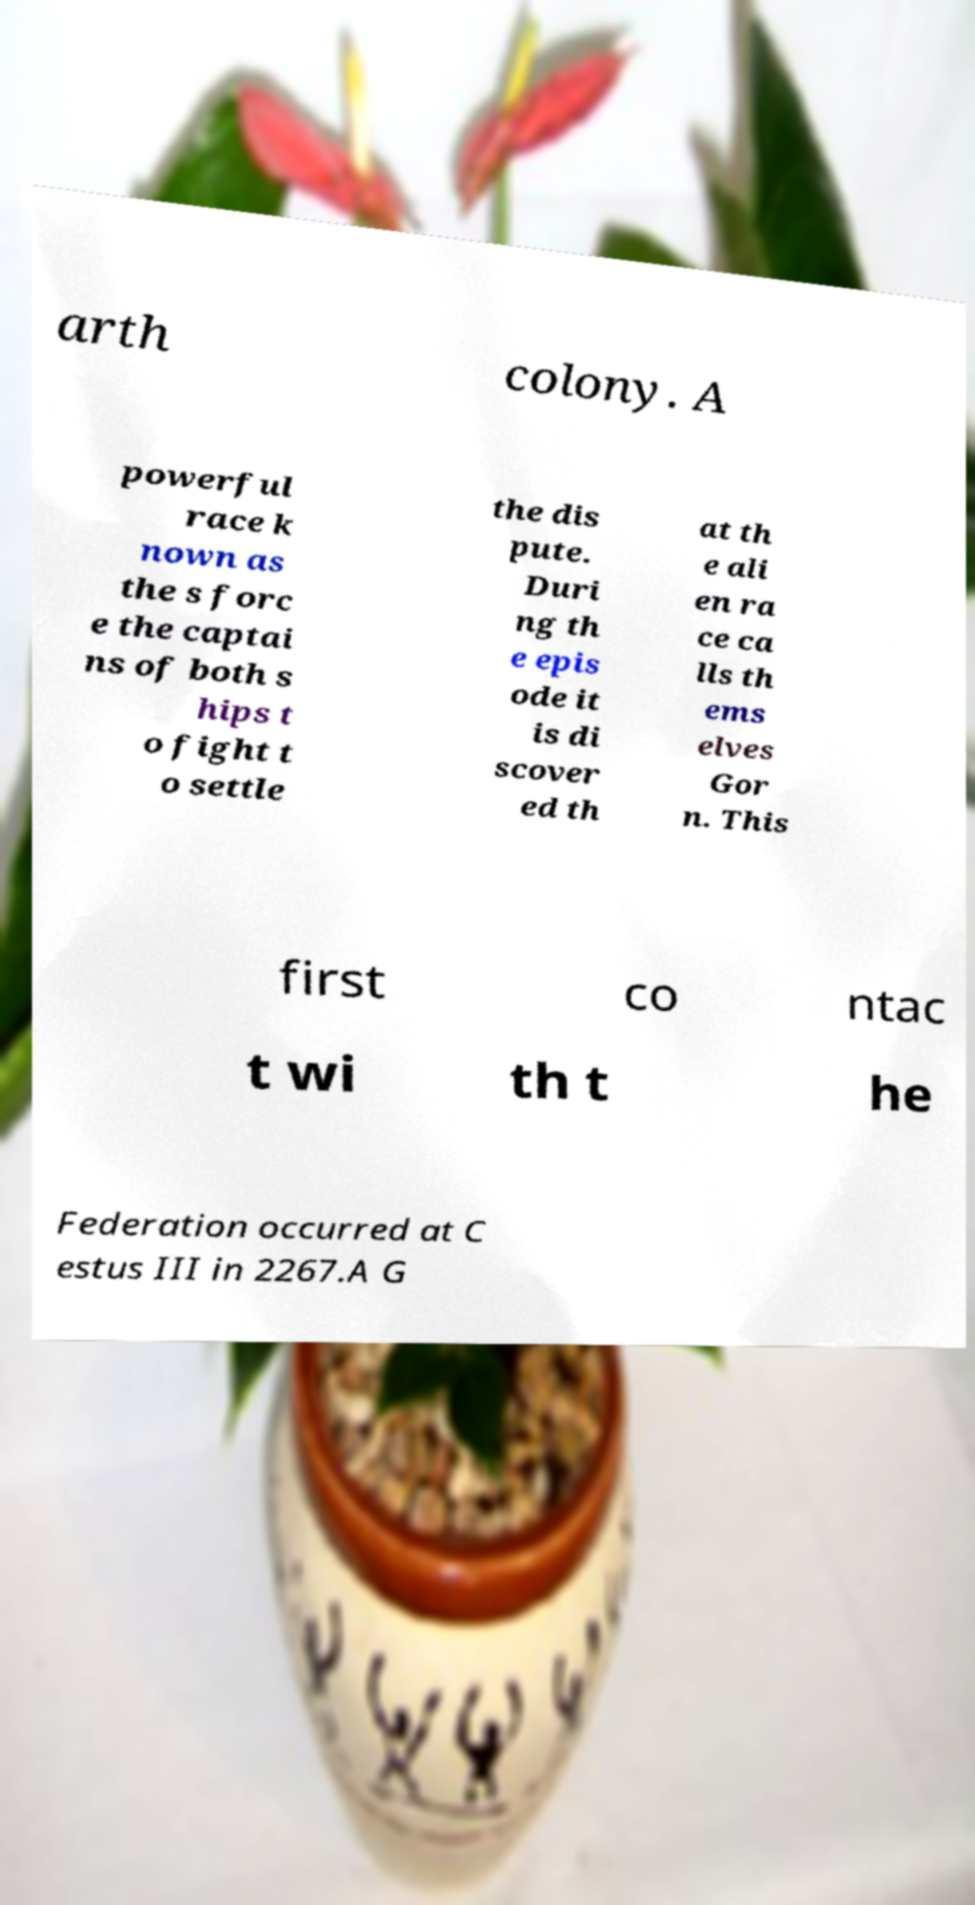I need the written content from this picture converted into text. Can you do that? arth colony. A powerful race k nown as the s forc e the captai ns of both s hips t o fight t o settle the dis pute. Duri ng th e epis ode it is di scover ed th at th e ali en ra ce ca lls th ems elves Gor n. This first co ntac t wi th t he Federation occurred at C estus III in 2267.A G 